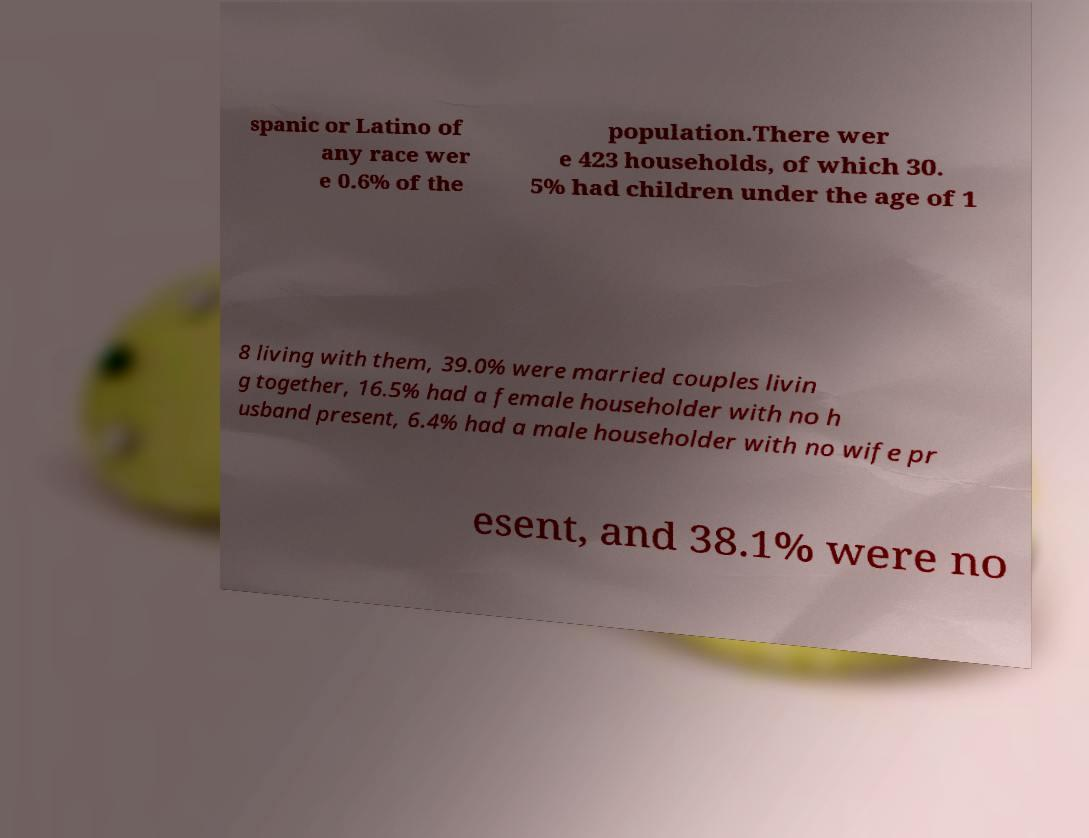Could you extract and type out the text from this image? spanic or Latino of any race wer e 0.6% of the population.There wer e 423 households, of which 30. 5% had children under the age of 1 8 living with them, 39.0% were married couples livin g together, 16.5% had a female householder with no h usband present, 6.4% had a male householder with no wife pr esent, and 38.1% were no 